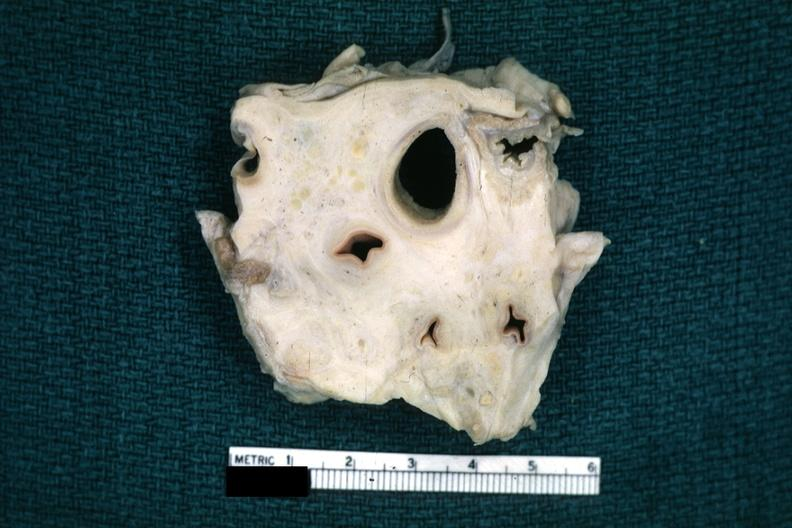how is fixed tissue trachea and arteries surrounded by tumor tissue horizontal section?
Answer the question using a single word or phrase. Dense 